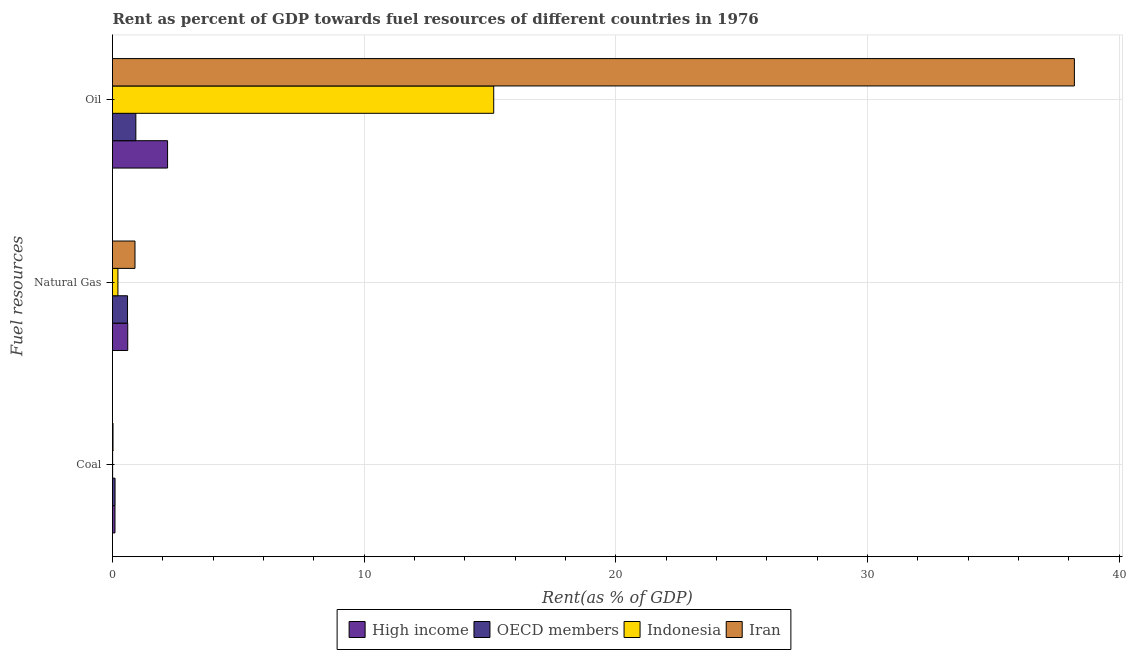How many different coloured bars are there?
Your answer should be very brief. 4. How many groups of bars are there?
Make the answer very short. 3. Are the number of bars per tick equal to the number of legend labels?
Provide a succinct answer. Yes. Are the number of bars on each tick of the Y-axis equal?
Your answer should be compact. Yes. How many bars are there on the 1st tick from the bottom?
Keep it short and to the point. 4. What is the label of the 2nd group of bars from the top?
Your answer should be very brief. Natural Gas. What is the rent towards oil in OECD members?
Ensure brevity in your answer.  0.93. Across all countries, what is the maximum rent towards oil?
Your answer should be compact. 38.22. Across all countries, what is the minimum rent towards oil?
Keep it short and to the point. 0.93. In which country was the rent towards oil maximum?
Your answer should be compact. Iran. What is the total rent towards coal in the graph?
Your response must be concise. 0.22. What is the difference between the rent towards oil in Iran and that in Indonesia?
Ensure brevity in your answer.  23.08. What is the difference between the rent towards coal in High income and the rent towards natural gas in Iran?
Provide a succinct answer. -0.8. What is the average rent towards oil per country?
Give a very brief answer. 14.12. What is the difference between the rent towards oil and rent towards coal in Indonesia?
Your response must be concise. 15.14. What is the ratio of the rent towards coal in Iran to that in High income?
Your answer should be compact. 0.21. Is the difference between the rent towards natural gas in Indonesia and Iran greater than the difference between the rent towards oil in Indonesia and Iran?
Keep it short and to the point. Yes. What is the difference between the highest and the second highest rent towards oil?
Your answer should be compact. 23.08. What is the difference between the highest and the lowest rent towards coal?
Your response must be concise. 0.1. In how many countries, is the rent towards oil greater than the average rent towards oil taken over all countries?
Offer a terse response. 2. What does the 1st bar from the top in Natural Gas represents?
Your answer should be compact. Iran. Is it the case that in every country, the sum of the rent towards coal and rent towards natural gas is greater than the rent towards oil?
Offer a very short reply. No. How many bars are there?
Provide a short and direct response. 12. Are all the bars in the graph horizontal?
Give a very brief answer. Yes. How many countries are there in the graph?
Offer a terse response. 4. Are the values on the major ticks of X-axis written in scientific E-notation?
Offer a terse response. No. Does the graph contain any zero values?
Provide a short and direct response. No. How many legend labels are there?
Offer a terse response. 4. What is the title of the graph?
Offer a terse response. Rent as percent of GDP towards fuel resources of different countries in 1976. Does "Thailand" appear as one of the legend labels in the graph?
Give a very brief answer. No. What is the label or title of the X-axis?
Make the answer very short. Rent(as % of GDP). What is the label or title of the Y-axis?
Your response must be concise. Fuel resources. What is the Rent(as % of GDP) of High income in Coal?
Make the answer very short. 0.1. What is the Rent(as % of GDP) of OECD members in Coal?
Provide a succinct answer. 0.1. What is the Rent(as % of GDP) in Indonesia in Coal?
Keep it short and to the point. 0. What is the Rent(as % of GDP) in Iran in Coal?
Offer a terse response. 0.02. What is the Rent(as % of GDP) in High income in Natural Gas?
Ensure brevity in your answer.  0.61. What is the Rent(as % of GDP) of OECD members in Natural Gas?
Your answer should be very brief. 0.6. What is the Rent(as % of GDP) of Indonesia in Natural Gas?
Provide a succinct answer. 0.22. What is the Rent(as % of GDP) of Iran in Natural Gas?
Your answer should be compact. 0.89. What is the Rent(as % of GDP) of High income in Oil?
Ensure brevity in your answer.  2.19. What is the Rent(as % of GDP) of OECD members in Oil?
Your response must be concise. 0.93. What is the Rent(as % of GDP) of Indonesia in Oil?
Keep it short and to the point. 15.15. What is the Rent(as % of GDP) in Iran in Oil?
Keep it short and to the point. 38.22. Across all Fuel resources, what is the maximum Rent(as % of GDP) of High income?
Keep it short and to the point. 2.19. Across all Fuel resources, what is the maximum Rent(as % of GDP) in OECD members?
Your response must be concise. 0.93. Across all Fuel resources, what is the maximum Rent(as % of GDP) of Indonesia?
Your response must be concise. 15.15. Across all Fuel resources, what is the maximum Rent(as % of GDP) of Iran?
Offer a terse response. 38.22. Across all Fuel resources, what is the minimum Rent(as % of GDP) in High income?
Offer a very short reply. 0.1. Across all Fuel resources, what is the minimum Rent(as % of GDP) in OECD members?
Your answer should be compact. 0.1. Across all Fuel resources, what is the minimum Rent(as % of GDP) in Indonesia?
Ensure brevity in your answer.  0. Across all Fuel resources, what is the minimum Rent(as % of GDP) of Iran?
Your answer should be compact. 0.02. What is the total Rent(as % of GDP) of High income in the graph?
Your answer should be compact. 2.89. What is the total Rent(as % of GDP) of OECD members in the graph?
Offer a very short reply. 1.63. What is the total Rent(as % of GDP) in Indonesia in the graph?
Provide a short and direct response. 15.37. What is the total Rent(as % of GDP) of Iran in the graph?
Provide a short and direct response. 39.14. What is the difference between the Rent(as % of GDP) in High income in Coal and that in Natural Gas?
Keep it short and to the point. -0.51. What is the difference between the Rent(as % of GDP) in OECD members in Coal and that in Natural Gas?
Make the answer very short. -0.5. What is the difference between the Rent(as % of GDP) in Indonesia in Coal and that in Natural Gas?
Your answer should be compact. -0.21. What is the difference between the Rent(as % of GDP) in Iran in Coal and that in Natural Gas?
Make the answer very short. -0.87. What is the difference between the Rent(as % of GDP) of High income in Coal and that in Oil?
Your response must be concise. -2.09. What is the difference between the Rent(as % of GDP) in OECD members in Coal and that in Oil?
Make the answer very short. -0.83. What is the difference between the Rent(as % of GDP) of Indonesia in Coal and that in Oil?
Ensure brevity in your answer.  -15.14. What is the difference between the Rent(as % of GDP) of Iran in Coal and that in Oil?
Provide a succinct answer. -38.2. What is the difference between the Rent(as % of GDP) in High income in Natural Gas and that in Oil?
Offer a terse response. -1.58. What is the difference between the Rent(as % of GDP) of OECD members in Natural Gas and that in Oil?
Your response must be concise. -0.33. What is the difference between the Rent(as % of GDP) in Indonesia in Natural Gas and that in Oil?
Ensure brevity in your answer.  -14.93. What is the difference between the Rent(as % of GDP) of Iran in Natural Gas and that in Oil?
Give a very brief answer. -37.33. What is the difference between the Rent(as % of GDP) of High income in Coal and the Rent(as % of GDP) of OECD members in Natural Gas?
Provide a succinct answer. -0.5. What is the difference between the Rent(as % of GDP) of High income in Coal and the Rent(as % of GDP) of Indonesia in Natural Gas?
Offer a very short reply. -0.12. What is the difference between the Rent(as % of GDP) in High income in Coal and the Rent(as % of GDP) in Iran in Natural Gas?
Keep it short and to the point. -0.8. What is the difference between the Rent(as % of GDP) in OECD members in Coal and the Rent(as % of GDP) in Indonesia in Natural Gas?
Offer a very short reply. -0.11. What is the difference between the Rent(as % of GDP) of OECD members in Coal and the Rent(as % of GDP) of Iran in Natural Gas?
Ensure brevity in your answer.  -0.79. What is the difference between the Rent(as % of GDP) of Indonesia in Coal and the Rent(as % of GDP) of Iran in Natural Gas?
Your response must be concise. -0.89. What is the difference between the Rent(as % of GDP) of High income in Coal and the Rent(as % of GDP) of OECD members in Oil?
Offer a very short reply. -0.83. What is the difference between the Rent(as % of GDP) of High income in Coal and the Rent(as % of GDP) of Indonesia in Oil?
Ensure brevity in your answer.  -15.05. What is the difference between the Rent(as % of GDP) in High income in Coal and the Rent(as % of GDP) in Iran in Oil?
Offer a terse response. -38.13. What is the difference between the Rent(as % of GDP) of OECD members in Coal and the Rent(as % of GDP) of Indonesia in Oil?
Offer a very short reply. -15.05. What is the difference between the Rent(as % of GDP) in OECD members in Coal and the Rent(as % of GDP) in Iran in Oil?
Your answer should be very brief. -38.12. What is the difference between the Rent(as % of GDP) of Indonesia in Coal and the Rent(as % of GDP) of Iran in Oil?
Your answer should be very brief. -38.22. What is the difference between the Rent(as % of GDP) in High income in Natural Gas and the Rent(as % of GDP) in OECD members in Oil?
Your response must be concise. -0.32. What is the difference between the Rent(as % of GDP) of High income in Natural Gas and the Rent(as % of GDP) of Indonesia in Oil?
Provide a succinct answer. -14.54. What is the difference between the Rent(as % of GDP) in High income in Natural Gas and the Rent(as % of GDP) in Iran in Oil?
Your answer should be very brief. -37.62. What is the difference between the Rent(as % of GDP) of OECD members in Natural Gas and the Rent(as % of GDP) of Indonesia in Oil?
Ensure brevity in your answer.  -14.55. What is the difference between the Rent(as % of GDP) of OECD members in Natural Gas and the Rent(as % of GDP) of Iran in Oil?
Provide a succinct answer. -37.63. What is the difference between the Rent(as % of GDP) in Indonesia in Natural Gas and the Rent(as % of GDP) in Iran in Oil?
Ensure brevity in your answer.  -38.01. What is the average Rent(as % of GDP) of High income per Fuel resources?
Keep it short and to the point. 0.96. What is the average Rent(as % of GDP) of OECD members per Fuel resources?
Keep it short and to the point. 0.54. What is the average Rent(as % of GDP) in Indonesia per Fuel resources?
Make the answer very short. 5.12. What is the average Rent(as % of GDP) of Iran per Fuel resources?
Offer a very short reply. 13.05. What is the difference between the Rent(as % of GDP) of High income and Rent(as % of GDP) of OECD members in Coal?
Give a very brief answer. -0. What is the difference between the Rent(as % of GDP) of High income and Rent(as % of GDP) of Indonesia in Coal?
Give a very brief answer. 0.09. What is the difference between the Rent(as % of GDP) in High income and Rent(as % of GDP) in Iran in Coal?
Your response must be concise. 0.08. What is the difference between the Rent(as % of GDP) of OECD members and Rent(as % of GDP) of Indonesia in Coal?
Make the answer very short. 0.1. What is the difference between the Rent(as % of GDP) of OECD members and Rent(as % of GDP) of Iran in Coal?
Your answer should be very brief. 0.08. What is the difference between the Rent(as % of GDP) in Indonesia and Rent(as % of GDP) in Iran in Coal?
Your answer should be very brief. -0.02. What is the difference between the Rent(as % of GDP) in High income and Rent(as % of GDP) in OECD members in Natural Gas?
Offer a very short reply. 0.01. What is the difference between the Rent(as % of GDP) in High income and Rent(as % of GDP) in Indonesia in Natural Gas?
Your answer should be compact. 0.39. What is the difference between the Rent(as % of GDP) of High income and Rent(as % of GDP) of Iran in Natural Gas?
Give a very brief answer. -0.29. What is the difference between the Rent(as % of GDP) of OECD members and Rent(as % of GDP) of Indonesia in Natural Gas?
Your response must be concise. 0.38. What is the difference between the Rent(as % of GDP) of OECD members and Rent(as % of GDP) of Iran in Natural Gas?
Make the answer very short. -0.3. What is the difference between the Rent(as % of GDP) of Indonesia and Rent(as % of GDP) of Iran in Natural Gas?
Make the answer very short. -0.68. What is the difference between the Rent(as % of GDP) in High income and Rent(as % of GDP) in OECD members in Oil?
Ensure brevity in your answer.  1.26. What is the difference between the Rent(as % of GDP) of High income and Rent(as % of GDP) of Indonesia in Oil?
Offer a very short reply. -12.96. What is the difference between the Rent(as % of GDP) in High income and Rent(as % of GDP) in Iran in Oil?
Make the answer very short. -36.04. What is the difference between the Rent(as % of GDP) in OECD members and Rent(as % of GDP) in Indonesia in Oil?
Give a very brief answer. -14.22. What is the difference between the Rent(as % of GDP) of OECD members and Rent(as % of GDP) of Iran in Oil?
Keep it short and to the point. -37.3. What is the difference between the Rent(as % of GDP) in Indonesia and Rent(as % of GDP) in Iran in Oil?
Offer a very short reply. -23.08. What is the ratio of the Rent(as % of GDP) in High income in Coal to that in Natural Gas?
Provide a succinct answer. 0.16. What is the ratio of the Rent(as % of GDP) of OECD members in Coal to that in Natural Gas?
Provide a succinct answer. 0.17. What is the ratio of the Rent(as % of GDP) in Indonesia in Coal to that in Natural Gas?
Provide a short and direct response. 0.02. What is the ratio of the Rent(as % of GDP) in Iran in Coal to that in Natural Gas?
Your answer should be very brief. 0.02. What is the ratio of the Rent(as % of GDP) of High income in Coal to that in Oil?
Your answer should be compact. 0.04. What is the ratio of the Rent(as % of GDP) in OECD members in Coal to that in Oil?
Ensure brevity in your answer.  0.11. What is the ratio of the Rent(as % of GDP) of High income in Natural Gas to that in Oil?
Your response must be concise. 0.28. What is the ratio of the Rent(as % of GDP) of OECD members in Natural Gas to that in Oil?
Offer a very short reply. 0.64. What is the ratio of the Rent(as % of GDP) in Indonesia in Natural Gas to that in Oil?
Your answer should be compact. 0.01. What is the ratio of the Rent(as % of GDP) of Iran in Natural Gas to that in Oil?
Ensure brevity in your answer.  0.02. What is the difference between the highest and the second highest Rent(as % of GDP) in High income?
Your answer should be very brief. 1.58. What is the difference between the highest and the second highest Rent(as % of GDP) in OECD members?
Make the answer very short. 0.33. What is the difference between the highest and the second highest Rent(as % of GDP) in Indonesia?
Your response must be concise. 14.93. What is the difference between the highest and the second highest Rent(as % of GDP) of Iran?
Keep it short and to the point. 37.33. What is the difference between the highest and the lowest Rent(as % of GDP) of High income?
Give a very brief answer. 2.09. What is the difference between the highest and the lowest Rent(as % of GDP) of OECD members?
Ensure brevity in your answer.  0.83. What is the difference between the highest and the lowest Rent(as % of GDP) of Indonesia?
Give a very brief answer. 15.14. What is the difference between the highest and the lowest Rent(as % of GDP) in Iran?
Provide a succinct answer. 38.2. 